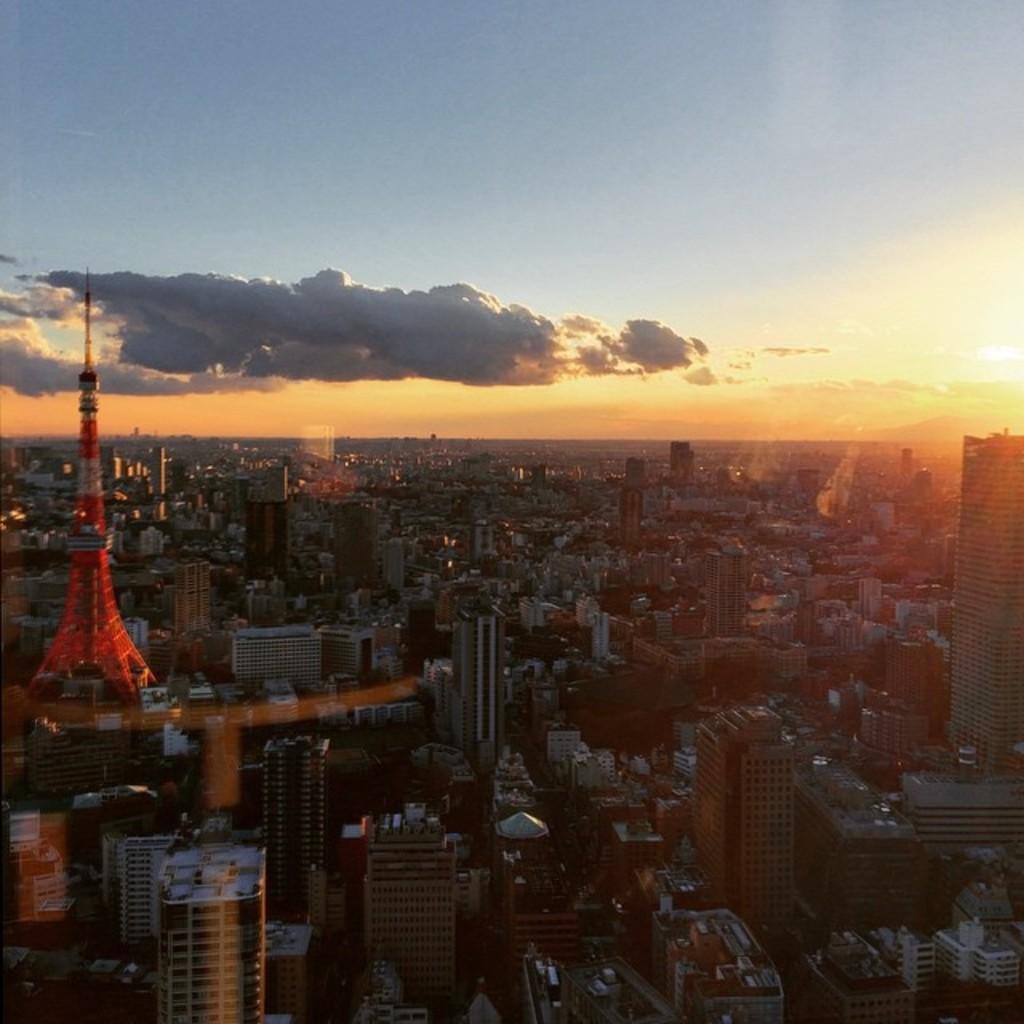Please provide a concise description of this image. In this picture we can see the top view of a city with buildings, trees, houses & a tower. At the top we can see clouds, sun and blue sky. 